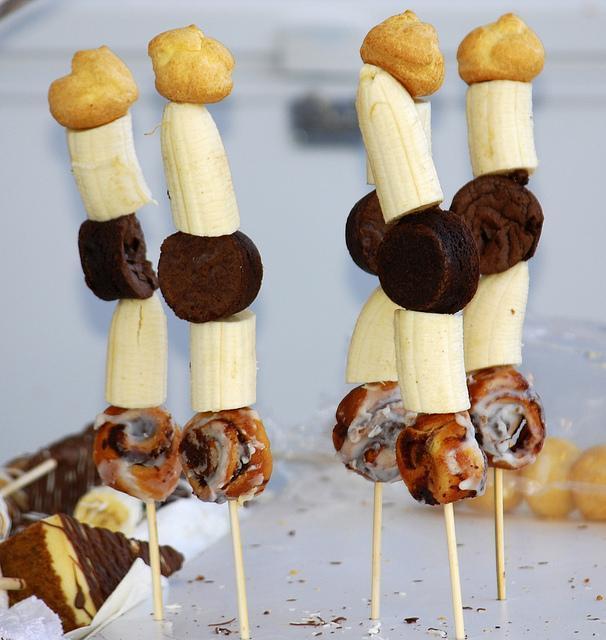How many donuts are there?
Give a very brief answer. 3. How many bananas are there?
Give a very brief answer. 9. 